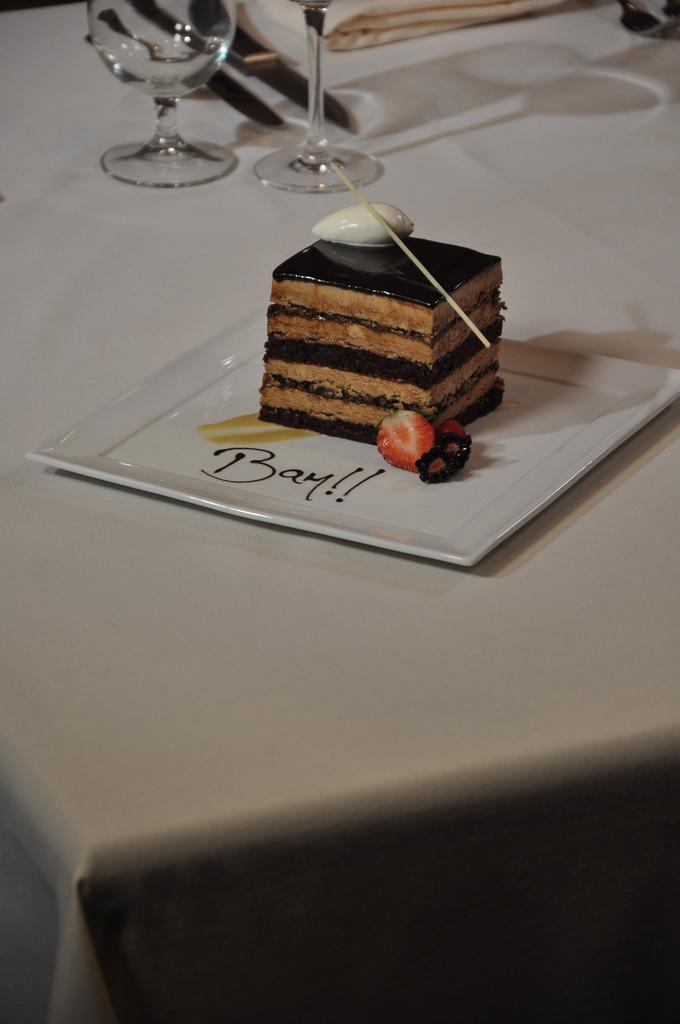How would you summarize this image in a sentence or two? In this image I can see a cake. And it is brown and black color. And it is on the plate. On the plate there is something is written. And there is also a strawberry on the plate. There are glasses,knife,and a plate on the table. 